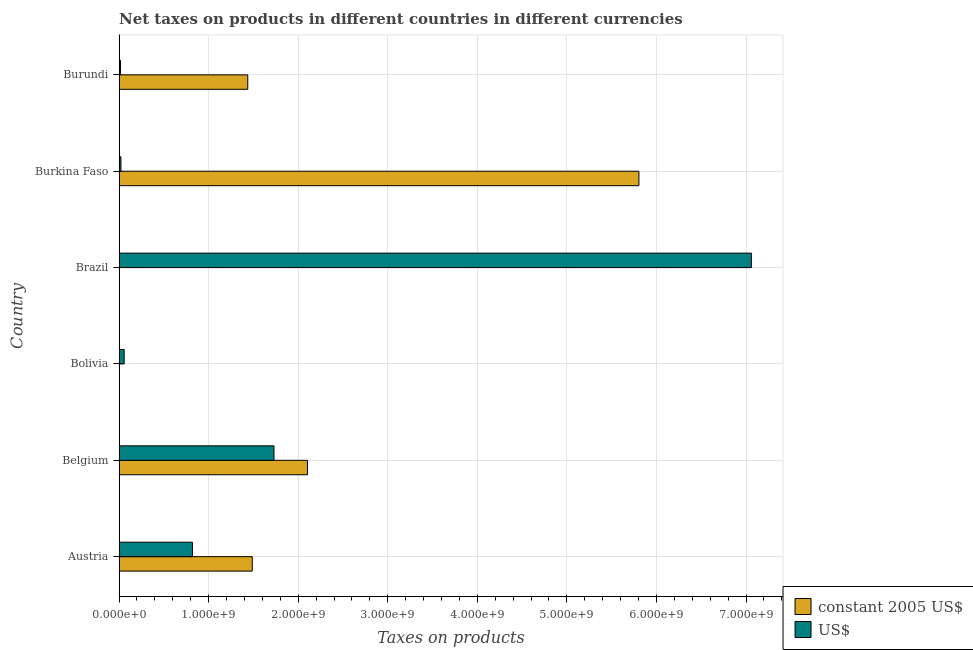How many different coloured bars are there?
Your answer should be compact. 2. How many bars are there on the 3rd tick from the top?
Your answer should be very brief. 2. What is the label of the 3rd group of bars from the top?
Your answer should be compact. Brazil. In how many cases, is the number of bars for a given country not equal to the number of legend labels?
Your answer should be compact. 0. What is the net taxes in us$ in Austria?
Keep it short and to the point. 8.19e+08. Across all countries, what is the maximum net taxes in us$?
Your response must be concise. 7.06e+09. Across all countries, what is the minimum net taxes in constant 2005 us$?
Offer a very short reply. 0.01. In which country was the net taxes in constant 2005 us$ maximum?
Keep it short and to the point. Burkina Faso. In which country was the net taxes in us$ minimum?
Give a very brief answer. Burundi. What is the total net taxes in us$ in the graph?
Ensure brevity in your answer.  9.70e+09. What is the difference between the net taxes in constant 2005 us$ in Austria and that in Burkina Faso?
Your response must be concise. -4.32e+09. What is the difference between the net taxes in constant 2005 us$ in Austria and the net taxes in us$ in Burkina Faso?
Offer a terse response. 1.47e+09. What is the average net taxes in constant 2005 us$ per country?
Give a very brief answer. 1.81e+09. What is the difference between the net taxes in us$ and net taxes in constant 2005 us$ in Burundi?
Provide a succinct answer. -1.42e+09. What is the ratio of the net taxes in constant 2005 us$ in Belgium to that in Brazil?
Give a very brief answer. 1.55e+11. What is the difference between the highest and the second highest net taxes in constant 2005 us$?
Give a very brief answer. 3.70e+09. What is the difference between the highest and the lowest net taxes in constant 2005 us$?
Your answer should be very brief. 5.80e+09. Is the sum of the net taxes in us$ in Brazil and Burkina Faso greater than the maximum net taxes in constant 2005 us$ across all countries?
Your answer should be compact. Yes. What does the 1st bar from the top in Belgium represents?
Provide a short and direct response. US$. What does the 2nd bar from the bottom in Bolivia represents?
Ensure brevity in your answer.  US$. Are all the bars in the graph horizontal?
Provide a short and direct response. Yes. What is the difference between two consecutive major ticks on the X-axis?
Your response must be concise. 1.00e+09. Are the values on the major ticks of X-axis written in scientific E-notation?
Your response must be concise. Yes. What is the title of the graph?
Provide a short and direct response. Net taxes on products in different countries in different currencies. Does "RDB nonconcessional" appear as one of the legend labels in the graph?
Provide a short and direct response. No. What is the label or title of the X-axis?
Make the answer very short. Taxes on products. What is the label or title of the Y-axis?
Provide a succinct answer. Country. What is the Taxes on products of constant 2005 US$ in Austria?
Provide a succinct answer. 1.49e+09. What is the Taxes on products in US$ in Austria?
Provide a short and direct response. 8.19e+08. What is the Taxes on products in constant 2005 US$ in Belgium?
Provide a short and direct response. 2.10e+09. What is the Taxes on products of US$ in Belgium?
Your answer should be compact. 1.73e+09. What is the Taxes on products in constant 2005 US$ in Bolivia?
Your answer should be very brief. 677. What is the Taxes on products of US$ in Bolivia?
Keep it short and to the point. 5.70e+07. What is the Taxes on products of constant 2005 US$ in Brazil?
Ensure brevity in your answer.  0.01. What is the Taxes on products in US$ in Brazil?
Your response must be concise. 7.06e+09. What is the Taxes on products of constant 2005 US$ in Burkina Faso?
Give a very brief answer. 5.80e+09. What is the Taxes on products of US$ in Burkina Faso?
Offer a terse response. 2.11e+07. What is the Taxes on products in constant 2005 US$ in Burundi?
Provide a short and direct response. 1.44e+09. What is the Taxes on products in US$ in Burundi?
Offer a very short reply. 1.64e+07. Across all countries, what is the maximum Taxes on products in constant 2005 US$?
Provide a succinct answer. 5.80e+09. Across all countries, what is the maximum Taxes on products of US$?
Provide a succinct answer. 7.06e+09. Across all countries, what is the minimum Taxes on products of constant 2005 US$?
Give a very brief answer. 0.01. Across all countries, what is the minimum Taxes on products of US$?
Make the answer very short. 1.64e+07. What is the total Taxes on products in constant 2005 US$ in the graph?
Ensure brevity in your answer.  1.08e+1. What is the total Taxes on products of US$ in the graph?
Offer a very short reply. 9.70e+09. What is the difference between the Taxes on products in constant 2005 US$ in Austria and that in Belgium?
Keep it short and to the point. -6.16e+08. What is the difference between the Taxes on products in US$ in Austria and that in Belgium?
Provide a short and direct response. -9.11e+08. What is the difference between the Taxes on products of constant 2005 US$ in Austria and that in Bolivia?
Ensure brevity in your answer.  1.49e+09. What is the difference between the Taxes on products of US$ in Austria and that in Bolivia?
Ensure brevity in your answer.  7.62e+08. What is the difference between the Taxes on products in constant 2005 US$ in Austria and that in Brazil?
Make the answer very short. 1.49e+09. What is the difference between the Taxes on products in US$ in Austria and that in Brazil?
Offer a very short reply. -6.24e+09. What is the difference between the Taxes on products of constant 2005 US$ in Austria and that in Burkina Faso?
Ensure brevity in your answer.  -4.32e+09. What is the difference between the Taxes on products in US$ in Austria and that in Burkina Faso?
Your response must be concise. 7.98e+08. What is the difference between the Taxes on products in constant 2005 US$ in Austria and that in Burundi?
Ensure brevity in your answer.  5.02e+07. What is the difference between the Taxes on products of US$ in Austria and that in Burundi?
Ensure brevity in your answer.  8.03e+08. What is the difference between the Taxes on products of constant 2005 US$ in Belgium and that in Bolivia?
Your response must be concise. 2.10e+09. What is the difference between the Taxes on products in US$ in Belgium and that in Bolivia?
Your answer should be compact. 1.67e+09. What is the difference between the Taxes on products in constant 2005 US$ in Belgium and that in Brazil?
Give a very brief answer. 2.10e+09. What is the difference between the Taxes on products of US$ in Belgium and that in Brazil?
Make the answer very short. -5.33e+09. What is the difference between the Taxes on products of constant 2005 US$ in Belgium and that in Burkina Faso?
Your answer should be very brief. -3.70e+09. What is the difference between the Taxes on products in US$ in Belgium and that in Burkina Faso?
Give a very brief answer. 1.71e+09. What is the difference between the Taxes on products in constant 2005 US$ in Belgium and that in Burundi?
Provide a succinct answer. 6.66e+08. What is the difference between the Taxes on products of US$ in Belgium and that in Burundi?
Your answer should be very brief. 1.71e+09. What is the difference between the Taxes on products of constant 2005 US$ in Bolivia and that in Brazil?
Ensure brevity in your answer.  676.99. What is the difference between the Taxes on products in US$ in Bolivia and that in Brazil?
Provide a succinct answer. -7.00e+09. What is the difference between the Taxes on products in constant 2005 US$ in Bolivia and that in Burkina Faso?
Your response must be concise. -5.80e+09. What is the difference between the Taxes on products in US$ in Bolivia and that in Burkina Faso?
Offer a very short reply. 3.59e+07. What is the difference between the Taxes on products of constant 2005 US$ in Bolivia and that in Burundi?
Provide a short and direct response. -1.44e+09. What is the difference between the Taxes on products of US$ in Bolivia and that in Burundi?
Offer a terse response. 4.06e+07. What is the difference between the Taxes on products in constant 2005 US$ in Brazil and that in Burkina Faso?
Offer a terse response. -5.80e+09. What is the difference between the Taxes on products in US$ in Brazil and that in Burkina Faso?
Your answer should be compact. 7.04e+09. What is the difference between the Taxes on products of constant 2005 US$ in Brazil and that in Burundi?
Offer a very short reply. -1.44e+09. What is the difference between the Taxes on products in US$ in Brazil and that in Burundi?
Keep it short and to the point. 7.04e+09. What is the difference between the Taxes on products in constant 2005 US$ in Burkina Faso and that in Burundi?
Your answer should be very brief. 4.37e+09. What is the difference between the Taxes on products of US$ in Burkina Faso and that in Burundi?
Make the answer very short. 4.65e+06. What is the difference between the Taxes on products of constant 2005 US$ in Austria and the Taxes on products of US$ in Belgium?
Provide a short and direct response. -2.42e+08. What is the difference between the Taxes on products in constant 2005 US$ in Austria and the Taxes on products in US$ in Bolivia?
Ensure brevity in your answer.  1.43e+09. What is the difference between the Taxes on products of constant 2005 US$ in Austria and the Taxes on products of US$ in Brazil?
Provide a short and direct response. -5.57e+09. What is the difference between the Taxes on products in constant 2005 US$ in Austria and the Taxes on products in US$ in Burkina Faso?
Give a very brief answer. 1.47e+09. What is the difference between the Taxes on products in constant 2005 US$ in Austria and the Taxes on products in US$ in Burundi?
Give a very brief answer. 1.47e+09. What is the difference between the Taxes on products in constant 2005 US$ in Belgium and the Taxes on products in US$ in Bolivia?
Offer a terse response. 2.05e+09. What is the difference between the Taxes on products in constant 2005 US$ in Belgium and the Taxes on products in US$ in Brazil?
Provide a succinct answer. -4.96e+09. What is the difference between the Taxes on products of constant 2005 US$ in Belgium and the Taxes on products of US$ in Burkina Faso?
Your answer should be compact. 2.08e+09. What is the difference between the Taxes on products in constant 2005 US$ in Belgium and the Taxes on products in US$ in Burundi?
Keep it short and to the point. 2.09e+09. What is the difference between the Taxes on products in constant 2005 US$ in Bolivia and the Taxes on products in US$ in Brazil?
Provide a short and direct response. -7.06e+09. What is the difference between the Taxes on products in constant 2005 US$ in Bolivia and the Taxes on products in US$ in Burkina Faso?
Provide a succinct answer. -2.11e+07. What is the difference between the Taxes on products of constant 2005 US$ in Bolivia and the Taxes on products of US$ in Burundi?
Give a very brief answer. -1.64e+07. What is the difference between the Taxes on products of constant 2005 US$ in Brazil and the Taxes on products of US$ in Burkina Faso?
Your answer should be very brief. -2.11e+07. What is the difference between the Taxes on products of constant 2005 US$ in Brazil and the Taxes on products of US$ in Burundi?
Make the answer very short. -1.64e+07. What is the difference between the Taxes on products of constant 2005 US$ in Burkina Faso and the Taxes on products of US$ in Burundi?
Make the answer very short. 5.79e+09. What is the average Taxes on products of constant 2005 US$ per country?
Your answer should be compact. 1.81e+09. What is the average Taxes on products in US$ per country?
Make the answer very short. 1.62e+09. What is the difference between the Taxes on products in constant 2005 US$ and Taxes on products in US$ in Austria?
Ensure brevity in your answer.  6.68e+08. What is the difference between the Taxes on products of constant 2005 US$ and Taxes on products of US$ in Belgium?
Ensure brevity in your answer.  3.74e+08. What is the difference between the Taxes on products in constant 2005 US$ and Taxes on products in US$ in Bolivia?
Offer a very short reply. -5.70e+07. What is the difference between the Taxes on products in constant 2005 US$ and Taxes on products in US$ in Brazil?
Provide a short and direct response. -7.06e+09. What is the difference between the Taxes on products of constant 2005 US$ and Taxes on products of US$ in Burkina Faso?
Your answer should be compact. 5.78e+09. What is the difference between the Taxes on products in constant 2005 US$ and Taxes on products in US$ in Burundi?
Ensure brevity in your answer.  1.42e+09. What is the ratio of the Taxes on products in constant 2005 US$ in Austria to that in Belgium?
Make the answer very short. 0.71. What is the ratio of the Taxes on products of US$ in Austria to that in Belgium?
Your answer should be very brief. 0.47. What is the ratio of the Taxes on products in constant 2005 US$ in Austria to that in Bolivia?
Keep it short and to the point. 2.20e+06. What is the ratio of the Taxes on products of US$ in Austria to that in Bolivia?
Provide a succinct answer. 14.37. What is the ratio of the Taxes on products of constant 2005 US$ in Austria to that in Brazil?
Keep it short and to the point. 1.10e+11. What is the ratio of the Taxes on products in US$ in Austria to that in Brazil?
Offer a terse response. 0.12. What is the ratio of the Taxes on products of constant 2005 US$ in Austria to that in Burkina Faso?
Ensure brevity in your answer.  0.26. What is the ratio of the Taxes on products of US$ in Austria to that in Burkina Faso?
Your response must be concise. 38.86. What is the ratio of the Taxes on products of constant 2005 US$ in Austria to that in Burundi?
Provide a short and direct response. 1.03. What is the ratio of the Taxes on products in US$ in Austria to that in Burundi?
Provide a succinct answer. 49.87. What is the ratio of the Taxes on products of constant 2005 US$ in Belgium to that in Bolivia?
Your response must be concise. 3.11e+06. What is the ratio of the Taxes on products of US$ in Belgium to that in Bolivia?
Provide a succinct answer. 30.35. What is the ratio of the Taxes on products of constant 2005 US$ in Belgium to that in Brazil?
Provide a succinct answer. 1.55e+11. What is the ratio of the Taxes on products of US$ in Belgium to that in Brazil?
Offer a terse response. 0.24. What is the ratio of the Taxes on products of constant 2005 US$ in Belgium to that in Burkina Faso?
Offer a very short reply. 0.36. What is the ratio of the Taxes on products in US$ in Belgium to that in Burkina Faso?
Make the answer very short. 82.06. What is the ratio of the Taxes on products of constant 2005 US$ in Belgium to that in Burundi?
Ensure brevity in your answer.  1.46. What is the ratio of the Taxes on products of US$ in Belgium to that in Burundi?
Provide a short and direct response. 105.32. What is the ratio of the Taxes on products of constant 2005 US$ in Bolivia to that in Brazil?
Provide a short and direct response. 4.99e+04. What is the ratio of the Taxes on products of US$ in Bolivia to that in Brazil?
Your answer should be very brief. 0.01. What is the ratio of the Taxes on products of constant 2005 US$ in Bolivia to that in Burkina Faso?
Offer a very short reply. 0. What is the ratio of the Taxes on products in US$ in Bolivia to that in Burkina Faso?
Make the answer very short. 2.7. What is the ratio of the Taxes on products of US$ in Bolivia to that in Burundi?
Ensure brevity in your answer.  3.47. What is the ratio of the Taxes on products in US$ in Brazil to that in Burkina Faso?
Keep it short and to the point. 334.94. What is the ratio of the Taxes on products in constant 2005 US$ in Brazil to that in Burundi?
Give a very brief answer. 0. What is the ratio of the Taxes on products in US$ in Brazil to that in Burundi?
Provide a succinct answer. 429.86. What is the ratio of the Taxes on products of constant 2005 US$ in Burkina Faso to that in Burundi?
Your answer should be compact. 4.04. What is the ratio of the Taxes on products of US$ in Burkina Faso to that in Burundi?
Your response must be concise. 1.28. What is the difference between the highest and the second highest Taxes on products in constant 2005 US$?
Give a very brief answer. 3.70e+09. What is the difference between the highest and the second highest Taxes on products in US$?
Provide a succinct answer. 5.33e+09. What is the difference between the highest and the lowest Taxes on products in constant 2005 US$?
Your answer should be compact. 5.80e+09. What is the difference between the highest and the lowest Taxes on products of US$?
Offer a terse response. 7.04e+09. 